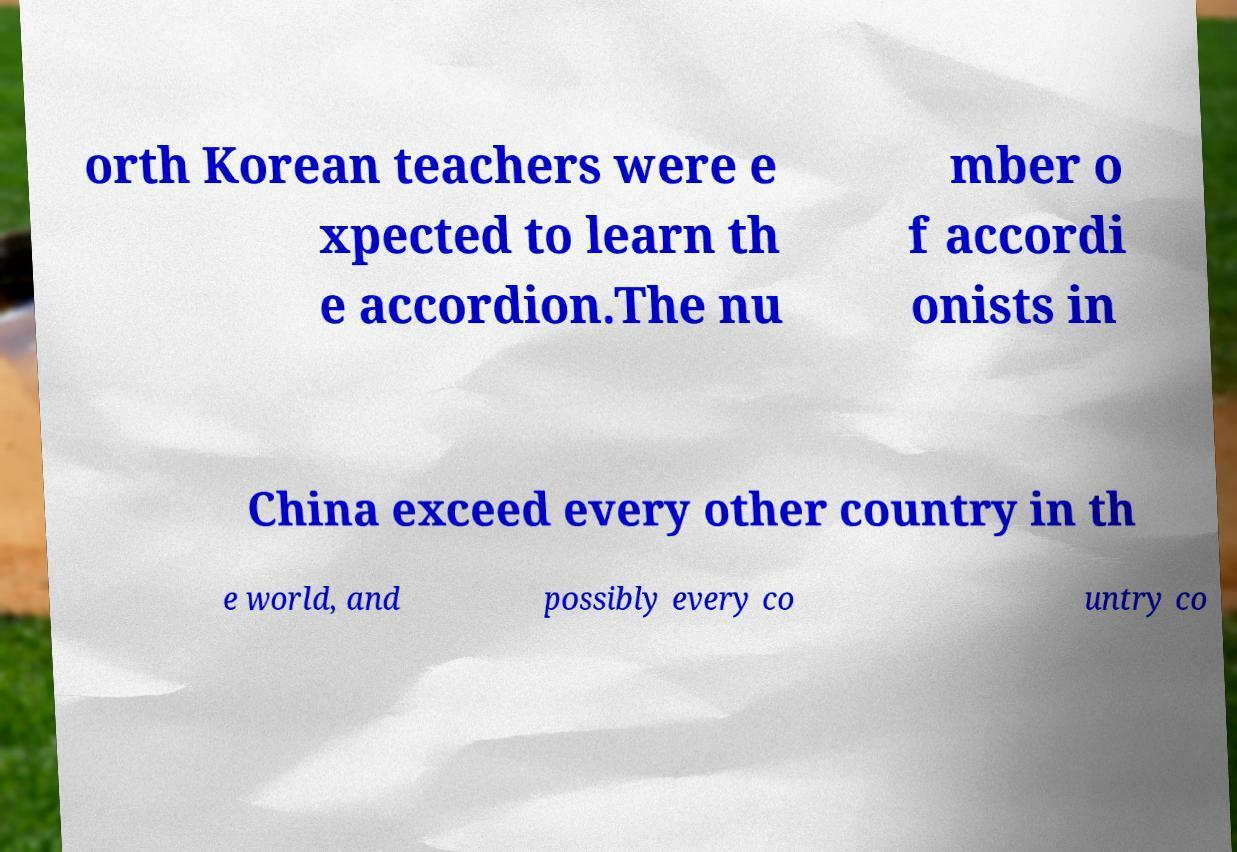Please read and relay the text visible in this image. What does it say? orth Korean teachers were e xpected to learn th e accordion.The nu mber o f accordi onists in China exceed every other country in th e world, and possibly every co untry co 